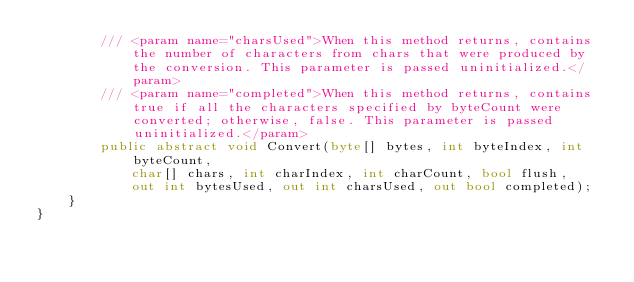Convert code to text. <code><loc_0><loc_0><loc_500><loc_500><_C#_>        /// <param name="charsUsed">When this method returns, contains the number of characters from chars that were produced by the conversion. This parameter is passed uninitialized.</param>
        /// <param name="completed">When this method returns, contains true if all the characters specified by byteCount were converted; otherwise, false. This parameter is passed uninitialized.</param>
        public abstract void Convert(byte[] bytes, int byteIndex, int byteCount,
            char[] chars, int charIndex, int charCount, bool flush,
            out int bytesUsed, out int charsUsed, out bool completed);
    }
}
</code> 